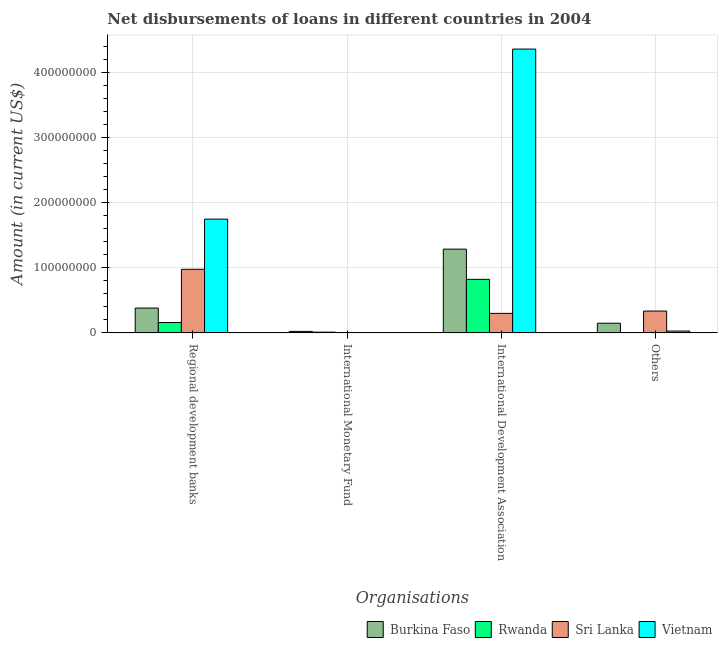How many different coloured bars are there?
Keep it short and to the point. 4. How many groups of bars are there?
Provide a short and direct response. 4. Are the number of bars per tick equal to the number of legend labels?
Provide a short and direct response. No. Are the number of bars on each tick of the X-axis equal?
Offer a terse response. No. How many bars are there on the 1st tick from the left?
Offer a terse response. 4. How many bars are there on the 4th tick from the right?
Make the answer very short. 4. What is the label of the 2nd group of bars from the left?
Your answer should be very brief. International Monetary Fund. What is the amount of loan disimbursed by regional development banks in Rwanda?
Your response must be concise. 1.59e+07. Across all countries, what is the maximum amount of loan disimbursed by regional development banks?
Your answer should be compact. 1.75e+08. In which country was the amount of loan disimbursed by other organisations maximum?
Your answer should be compact. Sri Lanka. What is the total amount of loan disimbursed by other organisations in the graph?
Offer a terse response. 5.11e+07. What is the difference between the amount of loan disimbursed by international development association in Sri Lanka and that in Vietnam?
Give a very brief answer. -4.06e+08. What is the difference between the amount of loan disimbursed by other organisations in Sri Lanka and the amount of loan disimbursed by international monetary fund in Vietnam?
Your answer should be compact. 3.35e+07. What is the average amount of loan disimbursed by international development association per country?
Offer a terse response. 1.69e+08. What is the difference between the amount of loan disimbursed by other organisations and amount of loan disimbursed by regional development banks in Sri Lanka?
Offer a terse response. -6.41e+07. What is the ratio of the amount of loan disimbursed by regional development banks in Rwanda to that in Vietnam?
Provide a short and direct response. 0.09. Is the amount of loan disimbursed by regional development banks in Vietnam less than that in Burkina Faso?
Make the answer very short. No. Is the difference between the amount of loan disimbursed by international development association in Rwanda and Sri Lanka greater than the difference between the amount of loan disimbursed by regional development banks in Rwanda and Sri Lanka?
Your response must be concise. Yes. What is the difference between the highest and the second highest amount of loan disimbursed by other organisations?
Your response must be concise. 1.87e+07. What is the difference between the highest and the lowest amount of loan disimbursed by other organisations?
Give a very brief answer. 3.35e+07. Is the sum of the amount of loan disimbursed by international development association in Vietnam and Burkina Faso greater than the maximum amount of loan disimbursed by international monetary fund across all countries?
Your response must be concise. Yes. How many bars are there?
Your answer should be very brief. 13. How many countries are there in the graph?
Offer a terse response. 4. Are the values on the major ticks of Y-axis written in scientific E-notation?
Offer a terse response. No. Does the graph contain any zero values?
Offer a very short reply. Yes. Where does the legend appear in the graph?
Keep it short and to the point. Bottom right. How many legend labels are there?
Offer a very short reply. 4. How are the legend labels stacked?
Your answer should be compact. Horizontal. What is the title of the graph?
Provide a succinct answer. Net disbursements of loans in different countries in 2004. Does "Denmark" appear as one of the legend labels in the graph?
Your answer should be very brief. No. What is the label or title of the X-axis?
Offer a very short reply. Organisations. What is the label or title of the Y-axis?
Give a very brief answer. Amount (in current US$). What is the Amount (in current US$) of Burkina Faso in Regional development banks?
Give a very brief answer. 3.81e+07. What is the Amount (in current US$) in Rwanda in Regional development banks?
Provide a succinct answer. 1.59e+07. What is the Amount (in current US$) in Sri Lanka in Regional development banks?
Give a very brief answer. 9.76e+07. What is the Amount (in current US$) in Vietnam in Regional development banks?
Ensure brevity in your answer.  1.75e+08. What is the Amount (in current US$) in Burkina Faso in International Monetary Fund?
Your response must be concise. 2.24e+06. What is the Amount (in current US$) in Rwanda in International Monetary Fund?
Your answer should be compact. 1.11e+06. What is the Amount (in current US$) in Burkina Faso in International Development Association?
Provide a short and direct response. 1.29e+08. What is the Amount (in current US$) in Rwanda in International Development Association?
Offer a terse response. 8.22e+07. What is the Amount (in current US$) in Sri Lanka in International Development Association?
Your answer should be compact. 2.99e+07. What is the Amount (in current US$) of Vietnam in International Development Association?
Your response must be concise. 4.36e+08. What is the Amount (in current US$) in Burkina Faso in Others?
Make the answer very short. 1.48e+07. What is the Amount (in current US$) of Sri Lanka in Others?
Provide a succinct answer. 3.35e+07. What is the Amount (in current US$) of Vietnam in Others?
Keep it short and to the point. 2.80e+06. Across all Organisations, what is the maximum Amount (in current US$) in Burkina Faso?
Offer a very short reply. 1.29e+08. Across all Organisations, what is the maximum Amount (in current US$) in Rwanda?
Your answer should be compact. 8.22e+07. Across all Organisations, what is the maximum Amount (in current US$) of Sri Lanka?
Ensure brevity in your answer.  9.76e+07. Across all Organisations, what is the maximum Amount (in current US$) of Vietnam?
Offer a terse response. 4.36e+08. Across all Organisations, what is the minimum Amount (in current US$) of Burkina Faso?
Your answer should be compact. 2.24e+06. Across all Organisations, what is the minimum Amount (in current US$) in Vietnam?
Give a very brief answer. 0. What is the total Amount (in current US$) of Burkina Faso in the graph?
Your answer should be compact. 1.84e+08. What is the total Amount (in current US$) in Rwanda in the graph?
Provide a succinct answer. 9.91e+07. What is the total Amount (in current US$) of Sri Lanka in the graph?
Your answer should be compact. 1.61e+08. What is the total Amount (in current US$) of Vietnam in the graph?
Provide a succinct answer. 6.13e+08. What is the difference between the Amount (in current US$) of Burkina Faso in Regional development banks and that in International Monetary Fund?
Make the answer very short. 3.59e+07. What is the difference between the Amount (in current US$) in Rwanda in Regional development banks and that in International Monetary Fund?
Offer a terse response. 1.47e+07. What is the difference between the Amount (in current US$) in Burkina Faso in Regional development banks and that in International Development Association?
Your answer should be very brief. -9.04e+07. What is the difference between the Amount (in current US$) in Rwanda in Regional development banks and that in International Development Association?
Offer a very short reply. -6.63e+07. What is the difference between the Amount (in current US$) in Sri Lanka in Regional development banks and that in International Development Association?
Offer a terse response. 6.76e+07. What is the difference between the Amount (in current US$) in Vietnam in Regional development banks and that in International Development Association?
Your answer should be very brief. -2.61e+08. What is the difference between the Amount (in current US$) in Burkina Faso in Regional development banks and that in Others?
Your answer should be compact. 2.33e+07. What is the difference between the Amount (in current US$) in Sri Lanka in Regional development banks and that in Others?
Give a very brief answer. 6.41e+07. What is the difference between the Amount (in current US$) in Vietnam in Regional development banks and that in Others?
Your answer should be very brief. 1.72e+08. What is the difference between the Amount (in current US$) in Burkina Faso in International Monetary Fund and that in International Development Association?
Give a very brief answer. -1.26e+08. What is the difference between the Amount (in current US$) of Rwanda in International Monetary Fund and that in International Development Association?
Give a very brief answer. -8.10e+07. What is the difference between the Amount (in current US$) of Burkina Faso in International Monetary Fund and that in Others?
Give a very brief answer. -1.26e+07. What is the difference between the Amount (in current US$) in Burkina Faso in International Development Association and that in Others?
Make the answer very short. 1.14e+08. What is the difference between the Amount (in current US$) of Sri Lanka in International Development Association and that in Others?
Provide a succinct answer. -3.56e+06. What is the difference between the Amount (in current US$) in Vietnam in International Development Association and that in Others?
Provide a short and direct response. 4.33e+08. What is the difference between the Amount (in current US$) in Burkina Faso in Regional development banks and the Amount (in current US$) in Rwanda in International Monetary Fund?
Ensure brevity in your answer.  3.70e+07. What is the difference between the Amount (in current US$) in Burkina Faso in Regional development banks and the Amount (in current US$) in Rwanda in International Development Association?
Your answer should be very brief. -4.41e+07. What is the difference between the Amount (in current US$) of Burkina Faso in Regional development banks and the Amount (in current US$) of Sri Lanka in International Development Association?
Offer a very short reply. 8.16e+06. What is the difference between the Amount (in current US$) of Burkina Faso in Regional development banks and the Amount (in current US$) of Vietnam in International Development Association?
Your answer should be very brief. -3.98e+08. What is the difference between the Amount (in current US$) of Rwanda in Regional development banks and the Amount (in current US$) of Sri Lanka in International Development Association?
Your response must be concise. -1.41e+07. What is the difference between the Amount (in current US$) in Rwanda in Regional development banks and the Amount (in current US$) in Vietnam in International Development Association?
Offer a very short reply. -4.20e+08. What is the difference between the Amount (in current US$) of Sri Lanka in Regional development banks and the Amount (in current US$) of Vietnam in International Development Association?
Ensure brevity in your answer.  -3.38e+08. What is the difference between the Amount (in current US$) of Burkina Faso in Regional development banks and the Amount (in current US$) of Sri Lanka in Others?
Keep it short and to the point. 4.61e+06. What is the difference between the Amount (in current US$) of Burkina Faso in Regional development banks and the Amount (in current US$) of Vietnam in Others?
Make the answer very short. 3.53e+07. What is the difference between the Amount (in current US$) in Rwanda in Regional development banks and the Amount (in current US$) in Sri Lanka in Others?
Your answer should be very brief. -1.76e+07. What is the difference between the Amount (in current US$) in Rwanda in Regional development banks and the Amount (in current US$) in Vietnam in Others?
Make the answer very short. 1.31e+07. What is the difference between the Amount (in current US$) in Sri Lanka in Regional development banks and the Amount (in current US$) in Vietnam in Others?
Your answer should be compact. 9.48e+07. What is the difference between the Amount (in current US$) in Burkina Faso in International Monetary Fund and the Amount (in current US$) in Rwanda in International Development Association?
Offer a very short reply. -7.99e+07. What is the difference between the Amount (in current US$) in Burkina Faso in International Monetary Fund and the Amount (in current US$) in Sri Lanka in International Development Association?
Your response must be concise. -2.77e+07. What is the difference between the Amount (in current US$) of Burkina Faso in International Monetary Fund and the Amount (in current US$) of Vietnam in International Development Association?
Offer a terse response. -4.33e+08. What is the difference between the Amount (in current US$) of Rwanda in International Monetary Fund and the Amount (in current US$) of Sri Lanka in International Development Association?
Make the answer very short. -2.88e+07. What is the difference between the Amount (in current US$) of Rwanda in International Monetary Fund and the Amount (in current US$) of Vietnam in International Development Association?
Give a very brief answer. -4.35e+08. What is the difference between the Amount (in current US$) of Burkina Faso in International Monetary Fund and the Amount (in current US$) of Sri Lanka in Others?
Give a very brief answer. -3.13e+07. What is the difference between the Amount (in current US$) in Burkina Faso in International Monetary Fund and the Amount (in current US$) in Vietnam in Others?
Offer a very short reply. -5.58e+05. What is the difference between the Amount (in current US$) in Rwanda in International Monetary Fund and the Amount (in current US$) in Sri Lanka in Others?
Your answer should be compact. -3.24e+07. What is the difference between the Amount (in current US$) in Rwanda in International Monetary Fund and the Amount (in current US$) in Vietnam in Others?
Ensure brevity in your answer.  -1.68e+06. What is the difference between the Amount (in current US$) of Burkina Faso in International Development Association and the Amount (in current US$) of Sri Lanka in Others?
Provide a succinct answer. 9.51e+07. What is the difference between the Amount (in current US$) of Burkina Faso in International Development Association and the Amount (in current US$) of Vietnam in Others?
Provide a succinct answer. 1.26e+08. What is the difference between the Amount (in current US$) in Rwanda in International Development Association and the Amount (in current US$) in Sri Lanka in Others?
Provide a short and direct response. 4.87e+07. What is the difference between the Amount (in current US$) of Rwanda in International Development Association and the Amount (in current US$) of Vietnam in Others?
Keep it short and to the point. 7.94e+07. What is the difference between the Amount (in current US$) of Sri Lanka in International Development Association and the Amount (in current US$) of Vietnam in Others?
Offer a terse response. 2.71e+07. What is the average Amount (in current US$) in Burkina Faso per Organisations?
Give a very brief answer. 4.59e+07. What is the average Amount (in current US$) in Rwanda per Organisations?
Offer a very short reply. 2.48e+07. What is the average Amount (in current US$) of Sri Lanka per Organisations?
Your answer should be compact. 4.03e+07. What is the average Amount (in current US$) in Vietnam per Organisations?
Ensure brevity in your answer.  1.53e+08. What is the difference between the Amount (in current US$) in Burkina Faso and Amount (in current US$) in Rwanda in Regional development banks?
Offer a terse response. 2.22e+07. What is the difference between the Amount (in current US$) of Burkina Faso and Amount (in current US$) of Sri Lanka in Regional development banks?
Offer a terse response. -5.95e+07. What is the difference between the Amount (in current US$) of Burkina Faso and Amount (in current US$) of Vietnam in Regional development banks?
Provide a succinct answer. -1.37e+08. What is the difference between the Amount (in current US$) of Rwanda and Amount (in current US$) of Sri Lanka in Regional development banks?
Ensure brevity in your answer.  -8.17e+07. What is the difference between the Amount (in current US$) in Rwanda and Amount (in current US$) in Vietnam in Regional development banks?
Offer a very short reply. -1.59e+08. What is the difference between the Amount (in current US$) in Sri Lanka and Amount (in current US$) in Vietnam in Regional development banks?
Your answer should be compact. -7.71e+07. What is the difference between the Amount (in current US$) in Burkina Faso and Amount (in current US$) in Rwanda in International Monetary Fund?
Your answer should be very brief. 1.12e+06. What is the difference between the Amount (in current US$) in Burkina Faso and Amount (in current US$) in Rwanda in International Development Association?
Offer a very short reply. 4.64e+07. What is the difference between the Amount (in current US$) of Burkina Faso and Amount (in current US$) of Sri Lanka in International Development Association?
Provide a succinct answer. 9.86e+07. What is the difference between the Amount (in current US$) of Burkina Faso and Amount (in current US$) of Vietnam in International Development Association?
Give a very brief answer. -3.07e+08. What is the difference between the Amount (in current US$) in Rwanda and Amount (in current US$) in Sri Lanka in International Development Association?
Offer a terse response. 5.22e+07. What is the difference between the Amount (in current US$) in Rwanda and Amount (in current US$) in Vietnam in International Development Association?
Your answer should be very brief. -3.54e+08. What is the difference between the Amount (in current US$) in Sri Lanka and Amount (in current US$) in Vietnam in International Development Association?
Ensure brevity in your answer.  -4.06e+08. What is the difference between the Amount (in current US$) of Burkina Faso and Amount (in current US$) of Sri Lanka in Others?
Make the answer very short. -1.87e+07. What is the difference between the Amount (in current US$) in Burkina Faso and Amount (in current US$) in Vietnam in Others?
Offer a very short reply. 1.20e+07. What is the difference between the Amount (in current US$) in Sri Lanka and Amount (in current US$) in Vietnam in Others?
Make the answer very short. 3.07e+07. What is the ratio of the Amount (in current US$) in Burkina Faso in Regional development banks to that in International Monetary Fund?
Your response must be concise. 17.02. What is the ratio of the Amount (in current US$) of Rwanda in Regional development banks to that in International Monetary Fund?
Your answer should be very brief. 14.25. What is the ratio of the Amount (in current US$) in Burkina Faso in Regional development banks to that in International Development Association?
Your answer should be compact. 0.3. What is the ratio of the Amount (in current US$) in Rwanda in Regional development banks to that in International Development Association?
Provide a succinct answer. 0.19. What is the ratio of the Amount (in current US$) of Sri Lanka in Regional development banks to that in International Development Association?
Offer a very short reply. 3.26. What is the ratio of the Amount (in current US$) in Vietnam in Regional development banks to that in International Development Association?
Provide a succinct answer. 0.4. What is the ratio of the Amount (in current US$) in Burkina Faso in Regional development banks to that in Others?
Keep it short and to the point. 2.57. What is the ratio of the Amount (in current US$) of Sri Lanka in Regional development banks to that in Others?
Offer a very short reply. 2.91. What is the ratio of the Amount (in current US$) of Vietnam in Regional development banks to that in Others?
Make the answer very short. 62.46. What is the ratio of the Amount (in current US$) in Burkina Faso in International Monetary Fund to that in International Development Association?
Offer a very short reply. 0.02. What is the ratio of the Amount (in current US$) in Rwanda in International Monetary Fund to that in International Development Association?
Your answer should be very brief. 0.01. What is the ratio of the Amount (in current US$) in Burkina Faso in International Monetary Fund to that in Others?
Provide a short and direct response. 0.15. What is the ratio of the Amount (in current US$) in Burkina Faso in International Development Association to that in Others?
Offer a terse response. 8.67. What is the ratio of the Amount (in current US$) of Sri Lanka in International Development Association to that in Others?
Offer a terse response. 0.89. What is the ratio of the Amount (in current US$) of Vietnam in International Development Association to that in Others?
Ensure brevity in your answer.  155.84. What is the difference between the highest and the second highest Amount (in current US$) in Burkina Faso?
Make the answer very short. 9.04e+07. What is the difference between the highest and the second highest Amount (in current US$) of Rwanda?
Provide a succinct answer. 6.63e+07. What is the difference between the highest and the second highest Amount (in current US$) of Sri Lanka?
Keep it short and to the point. 6.41e+07. What is the difference between the highest and the second highest Amount (in current US$) of Vietnam?
Your answer should be compact. 2.61e+08. What is the difference between the highest and the lowest Amount (in current US$) of Burkina Faso?
Your response must be concise. 1.26e+08. What is the difference between the highest and the lowest Amount (in current US$) in Rwanda?
Provide a succinct answer. 8.22e+07. What is the difference between the highest and the lowest Amount (in current US$) of Sri Lanka?
Make the answer very short. 9.76e+07. What is the difference between the highest and the lowest Amount (in current US$) of Vietnam?
Provide a succinct answer. 4.36e+08. 